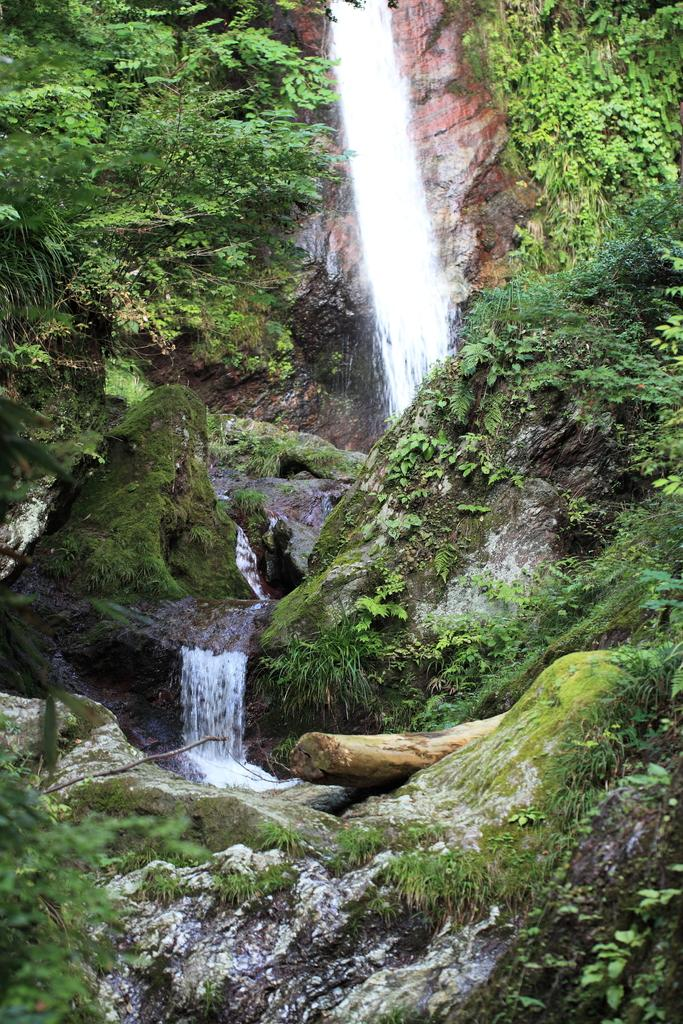What is visible in the image? Water, trees, and mountains are visible in the image. Can you describe the natural environment in the image? The image features a combination of water, trees, and mountains, which suggests a natural landscape. What type of vegetation can be seen in the image? Trees are visible in the image. Are there any geographical features present in the image? Yes, there are mountains in the image. How many slaves can be seen working in the fields in the image? There are no slaves or fields present in the image; it features water, trees, and mountains. What type of lizards can be seen crawling on the trees in the image? There are no lizards visible in the image; it only features water, trees, and mountains. 